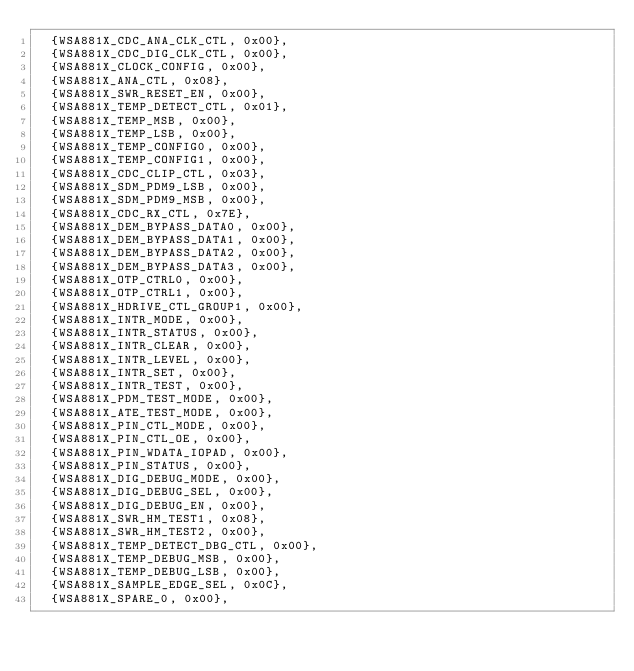Convert code to text. <code><loc_0><loc_0><loc_500><loc_500><_C_>	{WSA881X_CDC_ANA_CLK_CTL, 0x00},
	{WSA881X_CDC_DIG_CLK_CTL, 0x00},
	{WSA881X_CLOCK_CONFIG, 0x00},
	{WSA881X_ANA_CTL, 0x08},
	{WSA881X_SWR_RESET_EN, 0x00},
	{WSA881X_TEMP_DETECT_CTL, 0x01},
	{WSA881X_TEMP_MSB, 0x00},
	{WSA881X_TEMP_LSB, 0x00},
	{WSA881X_TEMP_CONFIG0, 0x00},
	{WSA881X_TEMP_CONFIG1, 0x00},
	{WSA881X_CDC_CLIP_CTL, 0x03},
	{WSA881X_SDM_PDM9_LSB, 0x00},
	{WSA881X_SDM_PDM9_MSB, 0x00},
	{WSA881X_CDC_RX_CTL, 0x7E},
	{WSA881X_DEM_BYPASS_DATA0, 0x00},
	{WSA881X_DEM_BYPASS_DATA1, 0x00},
	{WSA881X_DEM_BYPASS_DATA2, 0x00},
	{WSA881X_DEM_BYPASS_DATA3, 0x00},
	{WSA881X_OTP_CTRL0, 0x00},
	{WSA881X_OTP_CTRL1, 0x00},
	{WSA881X_HDRIVE_CTL_GROUP1, 0x00},
	{WSA881X_INTR_MODE, 0x00},
	{WSA881X_INTR_STATUS, 0x00},
	{WSA881X_INTR_CLEAR, 0x00},
	{WSA881X_INTR_LEVEL, 0x00},
	{WSA881X_INTR_SET, 0x00},
	{WSA881X_INTR_TEST, 0x00},
	{WSA881X_PDM_TEST_MODE, 0x00},
	{WSA881X_ATE_TEST_MODE, 0x00},
	{WSA881X_PIN_CTL_MODE, 0x00},
	{WSA881X_PIN_CTL_OE, 0x00},
	{WSA881X_PIN_WDATA_IOPAD, 0x00},
	{WSA881X_PIN_STATUS, 0x00},
	{WSA881X_DIG_DEBUG_MODE, 0x00},
	{WSA881X_DIG_DEBUG_SEL, 0x00},
	{WSA881X_DIG_DEBUG_EN, 0x00},
	{WSA881X_SWR_HM_TEST1, 0x08},
	{WSA881X_SWR_HM_TEST2, 0x00},
	{WSA881X_TEMP_DETECT_DBG_CTL, 0x00},
	{WSA881X_TEMP_DEBUG_MSB, 0x00},
	{WSA881X_TEMP_DEBUG_LSB, 0x00},
	{WSA881X_SAMPLE_EDGE_SEL, 0x0C},
	{WSA881X_SPARE_0, 0x00},</code> 